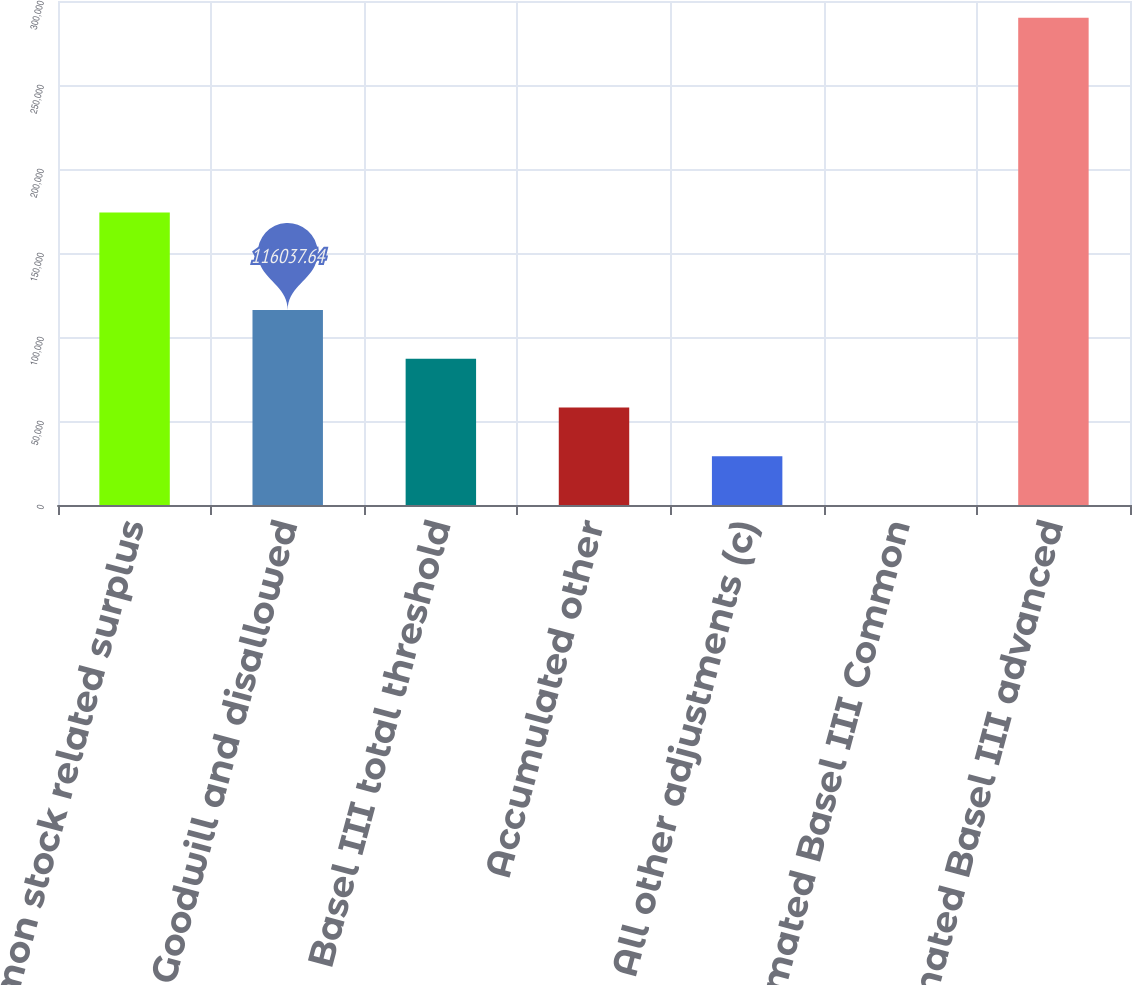Convert chart. <chart><loc_0><loc_0><loc_500><loc_500><bar_chart><fcel>Common stock related surplus<fcel>Goodwill and disallowed<fcel>Basel III total threshold<fcel>Accumulated other<fcel>All other adjustments (c)<fcel>Estimated Basel III Common<fcel>Estimated Basel III advanced<nl><fcel>174052<fcel>116038<fcel>87030.6<fcel>58023.5<fcel>29016.5<fcel>9.4<fcel>290080<nl></chart> 